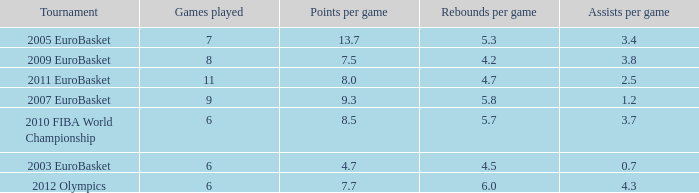How many games played have 4.7 points per game? 1.0. 